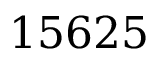Convert formula to latex. <formula><loc_0><loc_0><loc_500><loc_500>1 5 6 2 5</formula> 